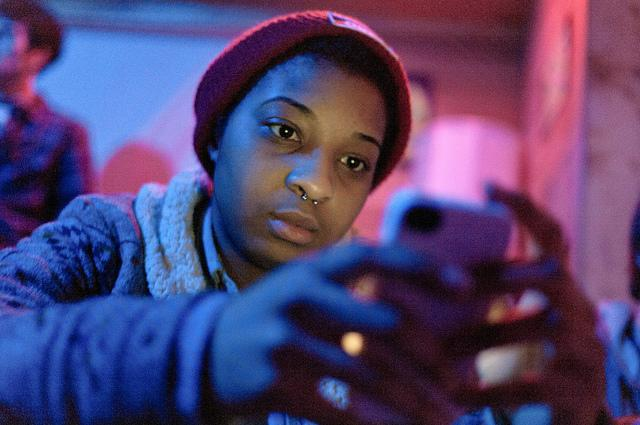What kind of media is she consuming? Please explain your reasoning. digital. The woman has her hands on her phone. 